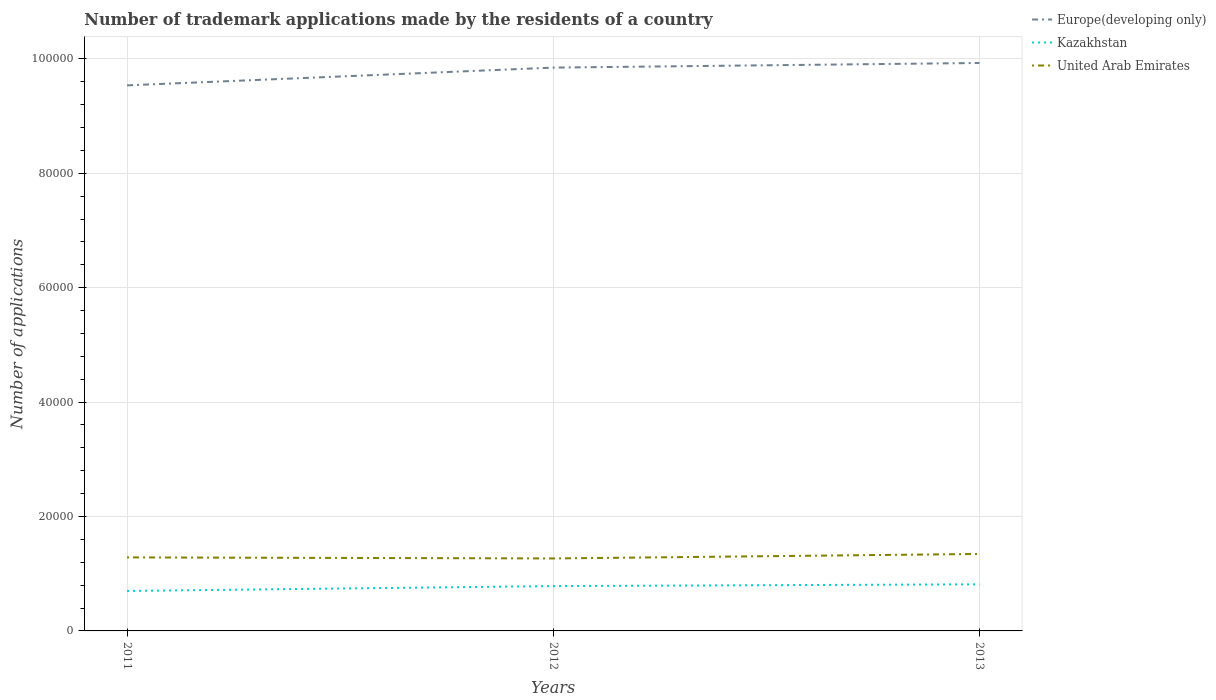Does the line corresponding to United Arab Emirates intersect with the line corresponding to Kazakhstan?
Offer a very short reply. No. Across all years, what is the maximum number of trademark applications made by the residents in United Arab Emirates?
Your answer should be compact. 1.27e+04. In which year was the number of trademark applications made by the residents in United Arab Emirates maximum?
Your answer should be very brief. 2012. What is the total number of trademark applications made by the residents in Europe(developing only) in the graph?
Offer a very short reply. -809. What is the difference between the highest and the second highest number of trademark applications made by the residents in United Arab Emirates?
Offer a terse response. 786. What is the difference between the highest and the lowest number of trademark applications made by the residents in Kazakhstan?
Offer a terse response. 2. How many lines are there?
Your answer should be compact. 3. What is the difference between two consecutive major ticks on the Y-axis?
Provide a succinct answer. 2.00e+04. Does the graph contain grids?
Offer a very short reply. Yes. How are the legend labels stacked?
Make the answer very short. Vertical. What is the title of the graph?
Provide a succinct answer. Number of trademark applications made by the residents of a country. Does "United Kingdom" appear as one of the legend labels in the graph?
Keep it short and to the point. No. What is the label or title of the Y-axis?
Offer a terse response. Number of applications. What is the Number of applications of Europe(developing only) in 2011?
Provide a short and direct response. 9.54e+04. What is the Number of applications in Kazakhstan in 2011?
Your answer should be very brief. 6985. What is the Number of applications of United Arab Emirates in 2011?
Your answer should be compact. 1.29e+04. What is the Number of applications in Europe(developing only) in 2012?
Provide a short and direct response. 9.85e+04. What is the Number of applications of Kazakhstan in 2012?
Your response must be concise. 7837. What is the Number of applications of United Arab Emirates in 2012?
Your response must be concise. 1.27e+04. What is the Number of applications in Europe(developing only) in 2013?
Your response must be concise. 9.93e+04. What is the Number of applications of Kazakhstan in 2013?
Make the answer very short. 8146. What is the Number of applications in United Arab Emirates in 2013?
Your answer should be compact. 1.35e+04. Across all years, what is the maximum Number of applications of Europe(developing only)?
Your response must be concise. 9.93e+04. Across all years, what is the maximum Number of applications in Kazakhstan?
Offer a terse response. 8146. Across all years, what is the maximum Number of applications in United Arab Emirates?
Offer a terse response. 1.35e+04. Across all years, what is the minimum Number of applications in Europe(developing only)?
Make the answer very short. 9.54e+04. Across all years, what is the minimum Number of applications in Kazakhstan?
Provide a short and direct response. 6985. Across all years, what is the minimum Number of applications in United Arab Emirates?
Your response must be concise. 1.27e+04. What is the total Number of applications of Europe(developing only) in the graph?
Give a very brief answer. 2.93e+05. What is the total Number of applications of Kazakhstan in the graph?
Offer a terse response. 2.30e+04. What is the total Number of applications of United Arab Emirates in the graph?
Make the answer very short. 3.90e+04. What is the difference between the Number of applications in Europe(developing only) in 2011 and that in 2012?
Your answer should be very brief. -3103. What is the difference between the Number of applications of Kazakhstan in 2011 and that in 2012?
Your answer should be compact. -852. What is the difference between the Number of applications in United Arab Emirates in 2011 and that in 2012?
Give a very brief answer. 183. What is the difference between the Number of applications in Europe(developing only) in 2011 and that in 2013?
Keep it short and to the point. -3912. What is the difference between the Number of applications in Kazakhstan in 2011 and that in 2013?
Make the answer very short. -1161. What is the difference between the Number of applications in United Arab Emirates in 2011 and that in 2013?
Provide a succinct answer. -603. What is the difference between the Number of applications in Europe(developing only) in 2012 and that in 2013?
Your answer should be very brief. -809. What is the difference between the Number of applications in Kazakhstan in 2012 and that in 2013?
Provide a short and direct response. -309. What is the difference between the Number of applications in United Arab Emirates in 2012 and that in 2013?
Make the answer very short. -786. What is the difference between the Number of applications of Europe(developing only) in 2011 and the Number of applications of Kazakhstan in 2012?
Keep it short and to the point. 8.75e+04. What is the difference between the Number of applications of Europe(developing only) in 2011 and the Number of applications of United Arab Emirates in 2012?
Your answer should be very brief. 8.27e+04. What is the difference between the Number of applications of Kazakhstan in 2011 and the Number of applications of United Arab Emirates in 2012?
Offer a terse response. -5683. What is the difference between the Number of applications in Europe(developing only) in 2011 and the Number of applications in Kazakhstan in 2013?
Your response must be concise. 8.72e+04. What is the difference between the Number of applications in Europe(developing only) in 2011 and the Number of applications in United Arab Emirates in 2013?
Provide a succinct answer. 8.19e+04. What is the difference between the Number of applications in Kazakhstan in 2011 and the Number of applications in United Arab Emirates in 2013?
Your answer should be very brief. -6469. What is the difference between the Number of applications of Europe(developing only) in 2012 and the Number of applications of Kazakhstan in 2013?
Give a very brief answer. 9.03e+04. What is the difference between the Number of applications of Europe(developing only) in 2012 and the Number of applications of United Arab Emirates in 2013?
Keep it short and to the point. 8.50e+04. What is the difference between the Number of applications of Kazakhstan in 2012 and the Number of applications of United Arab Emirates in 2013?
Keep it short and to the point. -5617. What is the average Number of applications in Europe(developing only) per year?
Offer a very short reply. 9.77e+04. What is the average Number of applications in Kazakhstan per year?
Your answer should be very brief. 7656. What is the average Number of applications of United Arab Emirates per year?
Make the answer very short. 1.30e+04. In the year 2011, what is the difference between the Number of applications of Europe(developing only) and Number of applications of Kazakhstan?
Provide a short and direct response. 8.84e+04. In the year 2011, what is the difference between the Number of applications of Europe(developing only) and Number of applications of United Arab Emirates?
Provide a short and direct response. 8.25e+04. In the year 2011, what is the difference between the Number of applications in Kazakhstan and Number of applications in United Arab Emirates?
Make the answer very short. -5866. In the year 2012, what is the difference between the Number of applications of Europe(developing only) and Number of applications of Kazakhstan?
Offer a terse response. 9.06e+04. In the year 2012, what is the difference between the Number of applications in Europe(developing only) and Number of applications in United Arab Emirates?
Your answer should be very brief. 8.58e+04. In the year 2012, what is the difference between the Number of applications in Kazakhstan and Number of applications in United Arab Emirates?
Give a very brief answer. -4831. In the year 2013, what is the difference between the Number of applications in Europe(developing only) and Number of applications in Kazakhstan?
Your answer should be compact. 9.11e+04. In the year 2013, what is the difference between the Number of applications in Europe(developing only) and Number of applications in United Arab Emirates?
Offer a terse response. 8.58e+04. In the year 2013, what is the difference between the Number of applications of Kazakhstan and Number of applications of United Arab Emirates?
Offer a terse response. -5308. What is the ratio of the Number of applications in Europe(developing only) in 2011 to that in 2012?
Give a very brief answer. 0.97. What is the ratio of the Number of applications of Kazakhstan in 2011 to that in 2012?
Your answer should be very brief. 0.89. What is the ratio of the Number of applications of United Arab Emirates in 2011 to that in 2012?
Offer a terse response. 1.01. What is the ratio of the Number of applications in Europe(developing only) in 2011 to that in 2013?
Provide a succinct answer. 0.96. What is the ratio of the Number of applications of Kazakhstan in 2011 to that in 2013?
Make the answer very short. 0.86. What is the ratio of the Number of applications in United Arab Emirates in 2011 to that in 2013?
Provide a succinct answer. 0.96. What is the ratio of the Number of applications of Europe(developing only) in 2012 to that in 2013?
Your answer should be very brief. 0.99. What is the ratio of the Number of applications of Kazakhstan in 2012 to that in 2013?
Your answer should be very brief. 0.96. What is the ratio of the Number of applications of United Arab Emirates in 2012 to that in 2013?
Provide a succinct answer. 0.94. What is the difference between the highest and the second highest Number of applications of Europe(developing only)?
Offer a terse response. 809. What is the difference between the highest and the second highest Number of applications in Kazakhstan?
Offer a very short reply. 309. What is the difference between the highest and the second highest Number of applications of United Arab Emirates?
Ensure brevity in your answer.  603. What is the difference between the highest and the lowest Number of applications of Europe(developing only)?
Your answer should be compact. 3912. What is the difference between the highest and the lowest Number of applications of Kazakhstan?
Give a very brief answer. 1161. What is the difference between the highest and the lowest Number of applications of United Arab Emirates?
Ensure brevity in your answer.  786. 